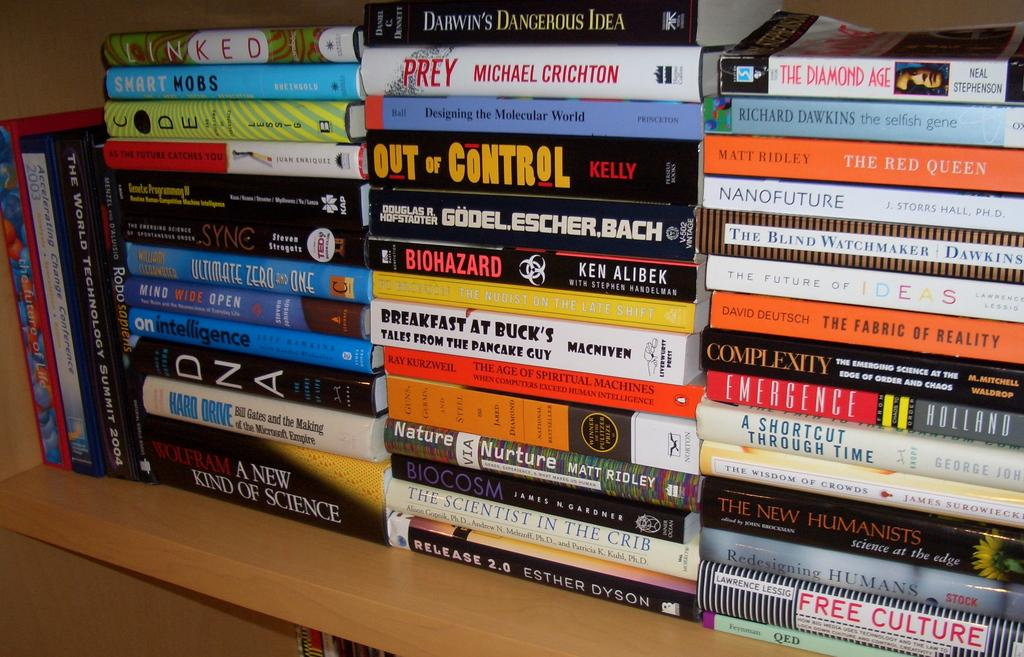What objects are on the wooden surface in the image? There are books on a wooden surface in the image. Can you describe the appearance of the books? The books have different colors. Is there any text or markings on the books? Yes, there is writing on the books. What type of lace is being used to hold the books together in the image? There is no lace present in the image; the books are simply placed on the wooden surface. 